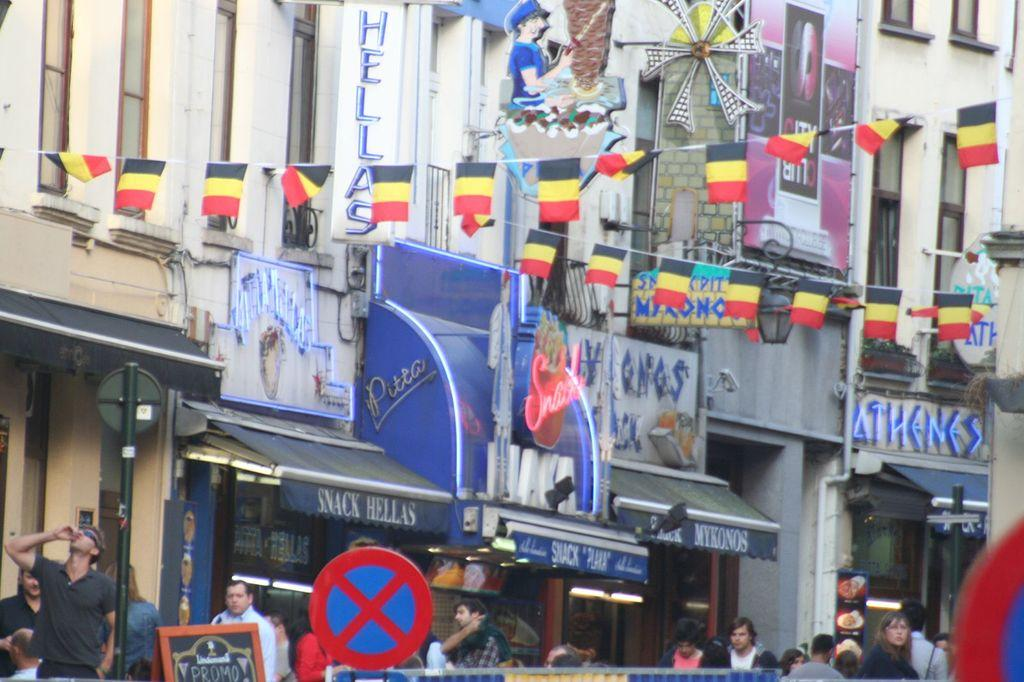What can be seen in the foreground of the image? There are sign boards in the foreground of the image. What is visible in the background of the image? There are persons, a pole, buildings, tents, and a banner in the background of the image. What type of decorations are present in the image? Bunting flags are present on the top of the image. Can you tell me how many geese are depicted on the banner in the image? There are no geese present in the image, and therefore no such depiction can be observed on the banner. What type of emotion does the goose feel in the image? There is no goose present in the image, so it is impossible to determine any emotions it might feel. 